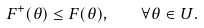<formula> <loc_0><loc_0><loc_500><loc_500>F ^ { + } ( \theta ) \leq F ( \theta ) , \quad \forall \theta \in U .</formula> 